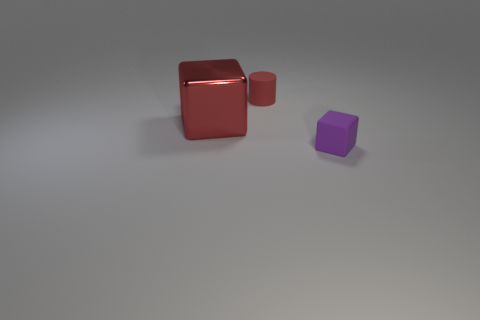Add 1 red rubber things. How many objects exist? 4 Subtract all cylinders. How many objects are left? 2 Subtract all brown cylinders. Subtract all tiny objects. How many objects are left? 1 Add 1 metallic things. How many metallic things are left? 2 Add 1 large things. How many large things exist? 2 Subtract 0 brown cylinders. How many objects are left? 3 